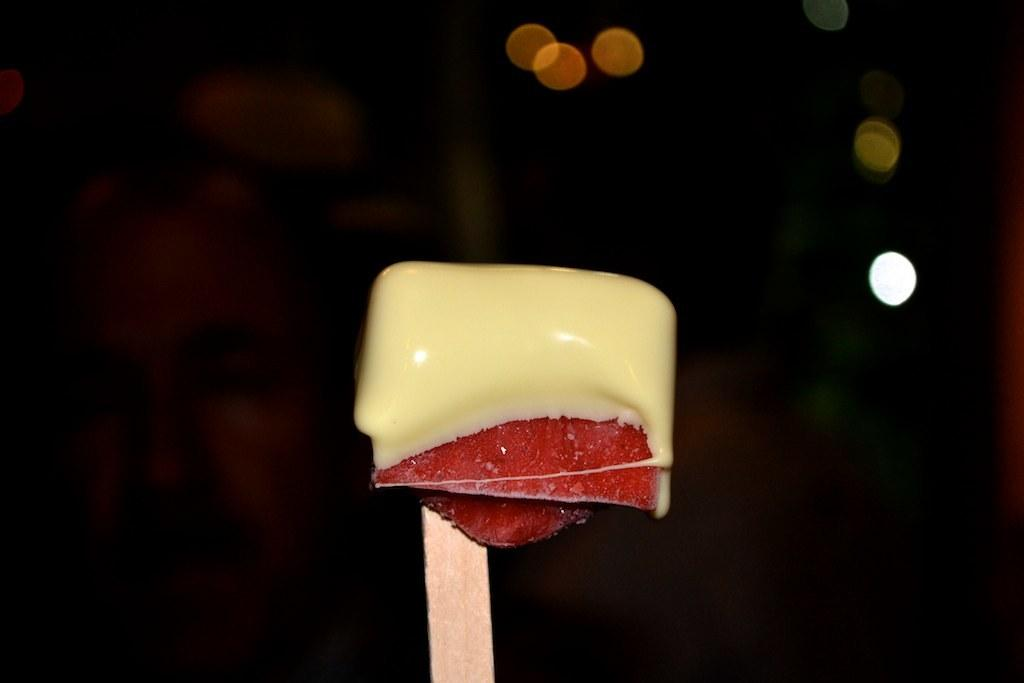What is the main subject of the image? There is an ice cream in the image. What else can be seen in the image besides the ice cream? There are lights visible in the image. How would you describe the overall color of the image? The image has a dark color. How many frogs are jumping around the ice cream in the image? There are no frogs present in the image. What type of town is visible in the background of the image? There is no town visible in the image; it only features an ice cream and lights. 